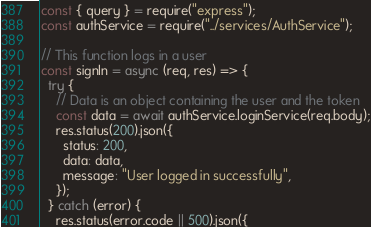<code> <loc_0><loc_0><loc_500><loc_500><_JavaScript_>const { query } = require("express");
const authService = require("../services/AuthService");

// This function logs in a user
const signIn = async (req, res) => {
  try {
    // Data is an object containing the user and the token
    const data = await authService.loginService(req.body);
    res.status(200).json({
      status: 200,
      data: data,
      message: "User logged in successfully",
    });
  } catch (error) {
    res.status(error.code || 500).json({</code> 